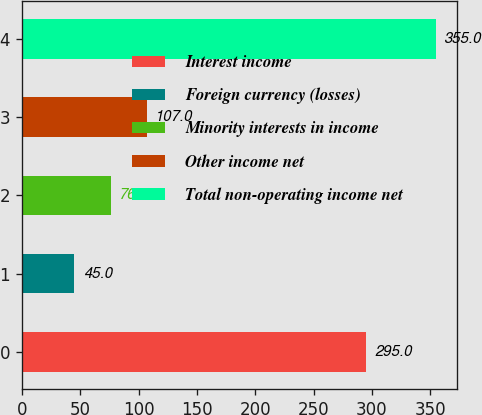Convert chart to OTSL. <chart><loc_0><loc_0><loc_500><loc_500><bar_chart><fcel>Interest income<fcel>Foreign currency (losses)<fcel>Minority interests in income<fcel>Other income net<fcel>Total non-operating income net<nl><fcel>295<fcel>45<fcel>76<fcel>107<fcel>355<nl></chart> 